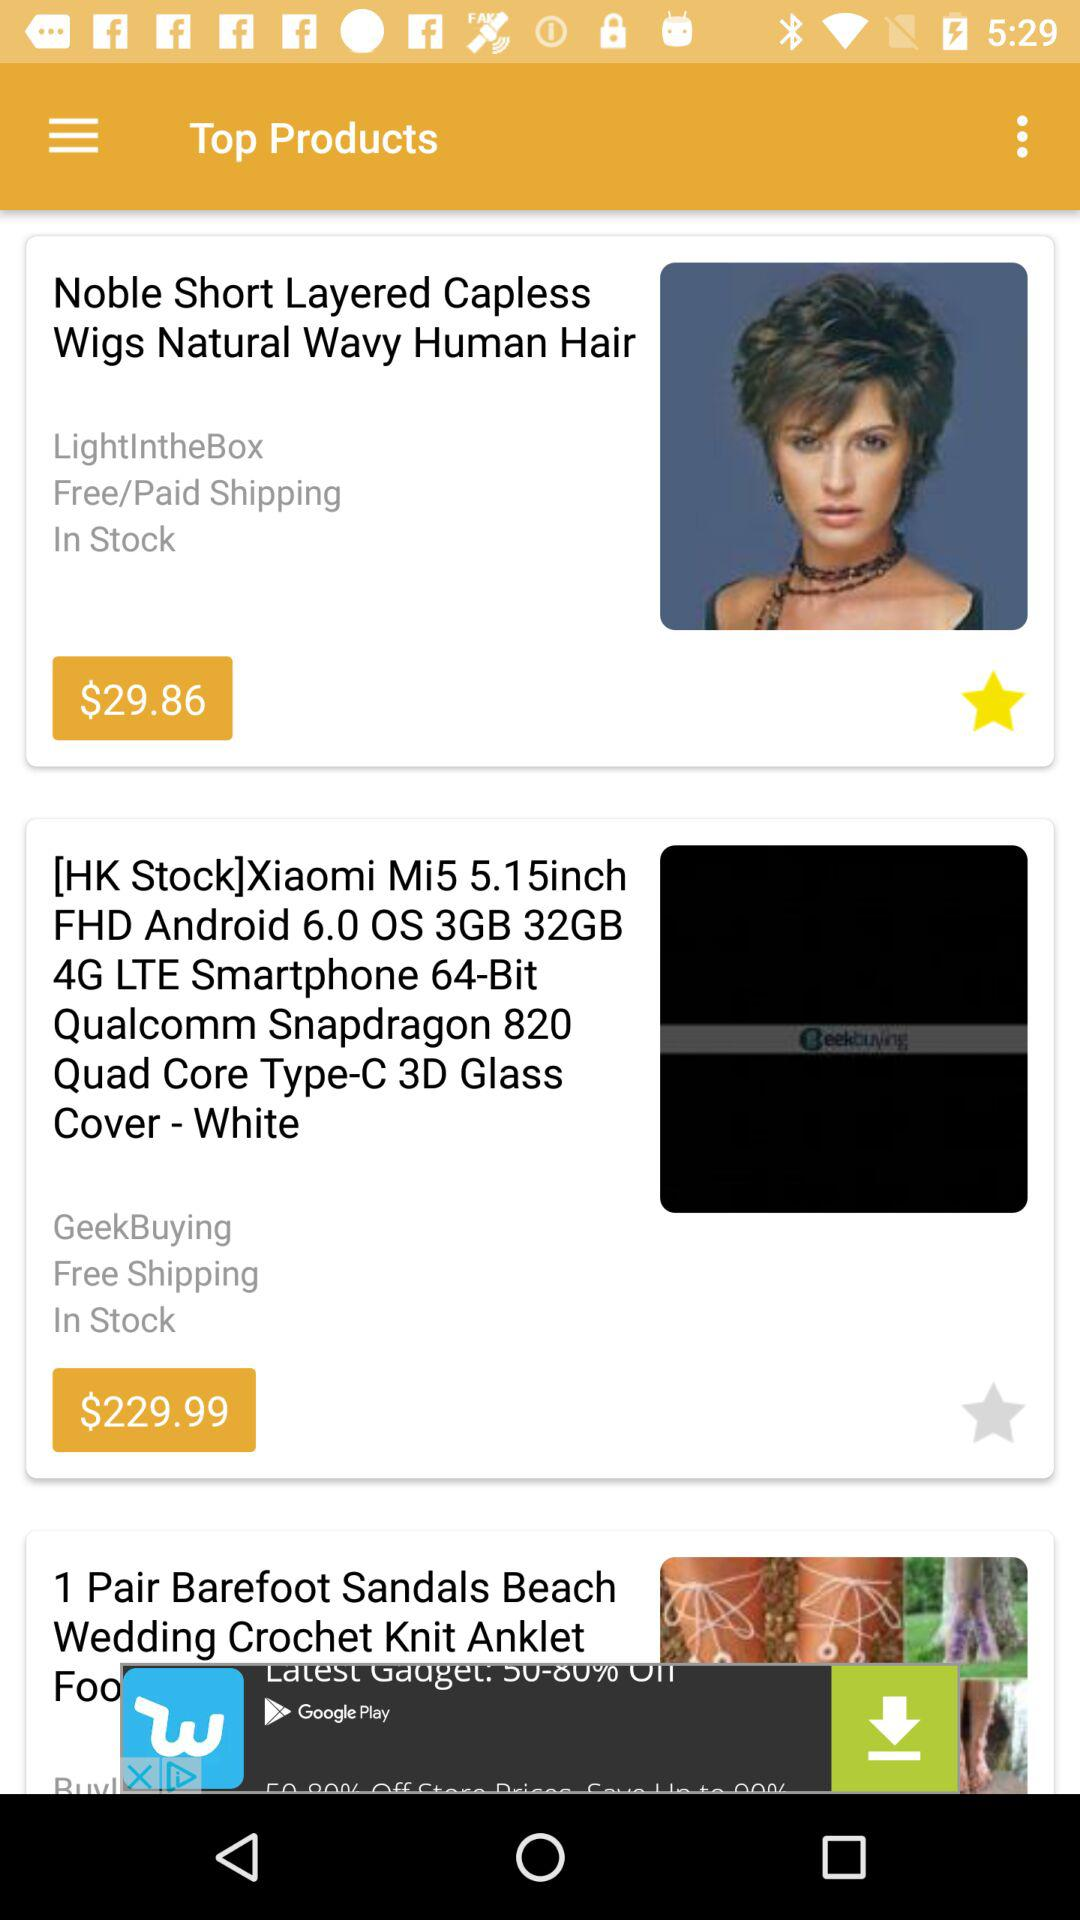What is the price of "Noble Short Layered Capless Wigs Natural Wavy Human Hair"? The price is $29.86. 